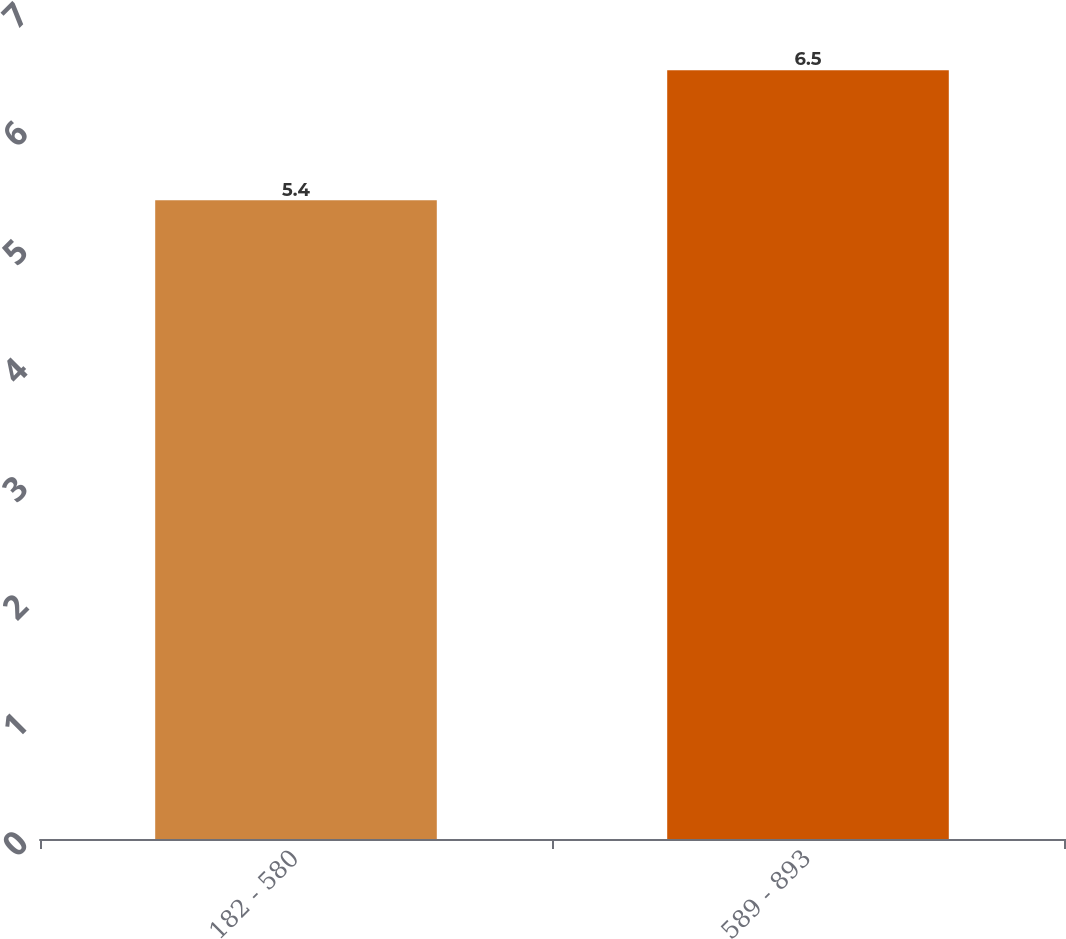Convert chart. <chart><loc_0><loc_0><loc_500><loc_500><bar_chart><fcel>182 - 580<fcel>589 - 893<nl><fcel>5.4<fcel>6.5<nl></chart> 